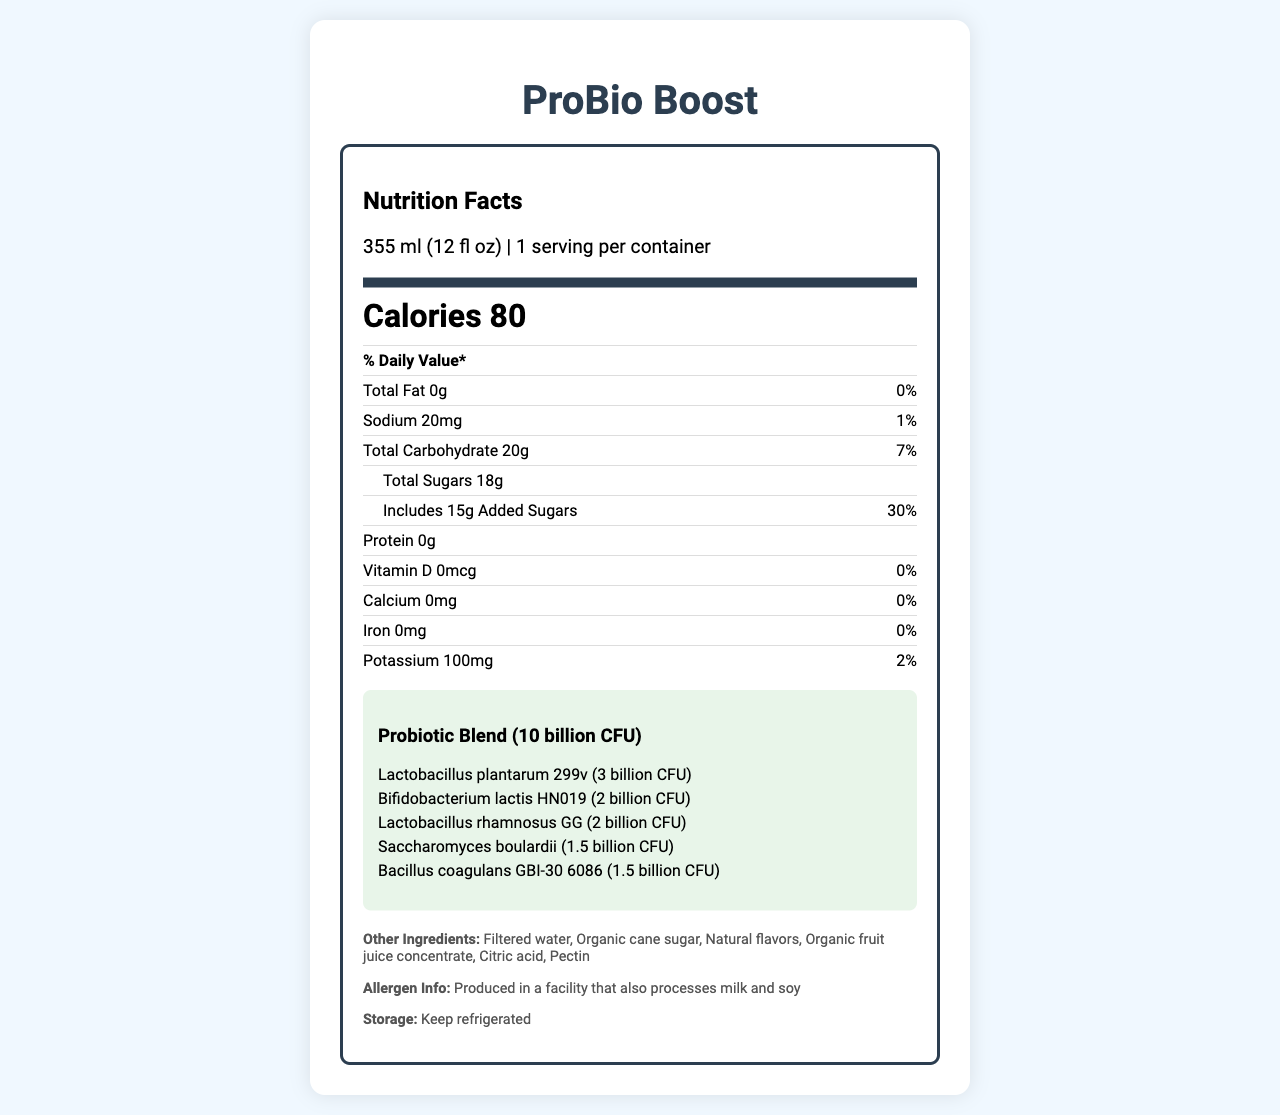what is the serving size of ProBio Boost? The serving size is mentioned in the document at the beginning under the product name section.
Answer: 355 ml (12 fl oz) how many servings are there per container? The document lists 1 serving per container under the serving size information.
Answer: 1 what is the total amount of probiotic blend per serving? The total probiotic blend is mentioned under the probiotic blend section.
Answer: 10 billion CFU which probiotic strain has the highest amount per serving? This strain has 3 billion CFU, which is the highest among all the listed strains.
Answer: Lactobacillus plantarum 299v how many grams of added sugars does ProBio Boost contain? The added sugars amount is specified under the total sugars information.
Answer: 15g what is the daily value percentage of sodium per serving? The sodium daily value percentage is listed in the document's nutrient information.
Answer: 1% true or false: ProBio Boost contains some amount of calcium. The document states that the amount of calcium is 0mg, resulting in a daily value of 0%.
Answer: False how should ProBio Boost be stored? The storage instructions mention that the product should be kept refrigerated.
Answer: Keep refrigerated how many calories does one serving of ProBio Boost have? The calorie information is highlighted in the document.
Answer: 80 what is the target audience for ProBio Boost? A. Children B. Health-conscious consumers C. Senior citizens The document mentions health-conscious consumers as part of the target audience in the entrepreneurial highlights section.
Answer: B which of the following ingredients is not in ProBio Boost? A. Organic cane sugar B. Citric acid C. High fructose corn syrup D. Pectin High fructose corn syrup is not listed among the ingredients.
Answer: C can we determine the individual amounts of each ingredient besides the probiotic blend from the document? The document provides the names of the ingredients but does not specify their individual amounts.
Answer: No summarize the main idea of the document. The summary includes key nutritional details, ingredient list, and entrepreneurial highlights mentioned in the document.
Answer: The document provides detailed nutritional information for ProBio Boost, a functional beverage rich in probiotics. It highlights serving size, calorie count, nutrient amounts, probiotic strains, other ingredients, storage instructions, and entrepreneurial insights like unique selling points and potential target audience. 